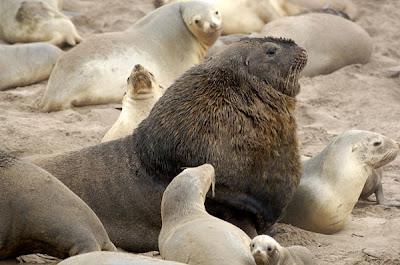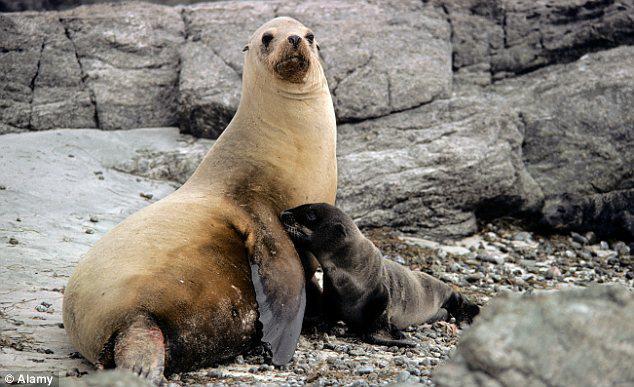The first image is the image on the left, the second image is the image on the right. Given the left and right images, does the statement "An image shows exactly one dark baby seal in contact with a larger, paler seal." hold true? Answer yes or no. Yes. 